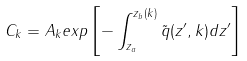<formula> <loc_0><loc_0><loc_500><loc_500>C _ { k } = A _ { k } e x p \left [ - \int _ { z _ { a } } ^ { z _ { b } ( k ) } \tilde { q } ( z ^ { \prime } , k ) d z ^ { \prime } \right ]</formula> 